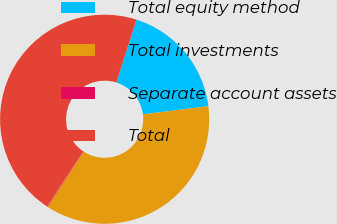Convert chart to OTSL. <chart><loc_0><loc_0><loc_500><loc_500><pie_chart><fcel>Total equity method<fcel>Total investments<fcel>Separate account assets<fcel>Total<nl><fcel>18.08%<fcel>36.21%<fcel>0.11%<fcel>45.6%<nl></chart> 